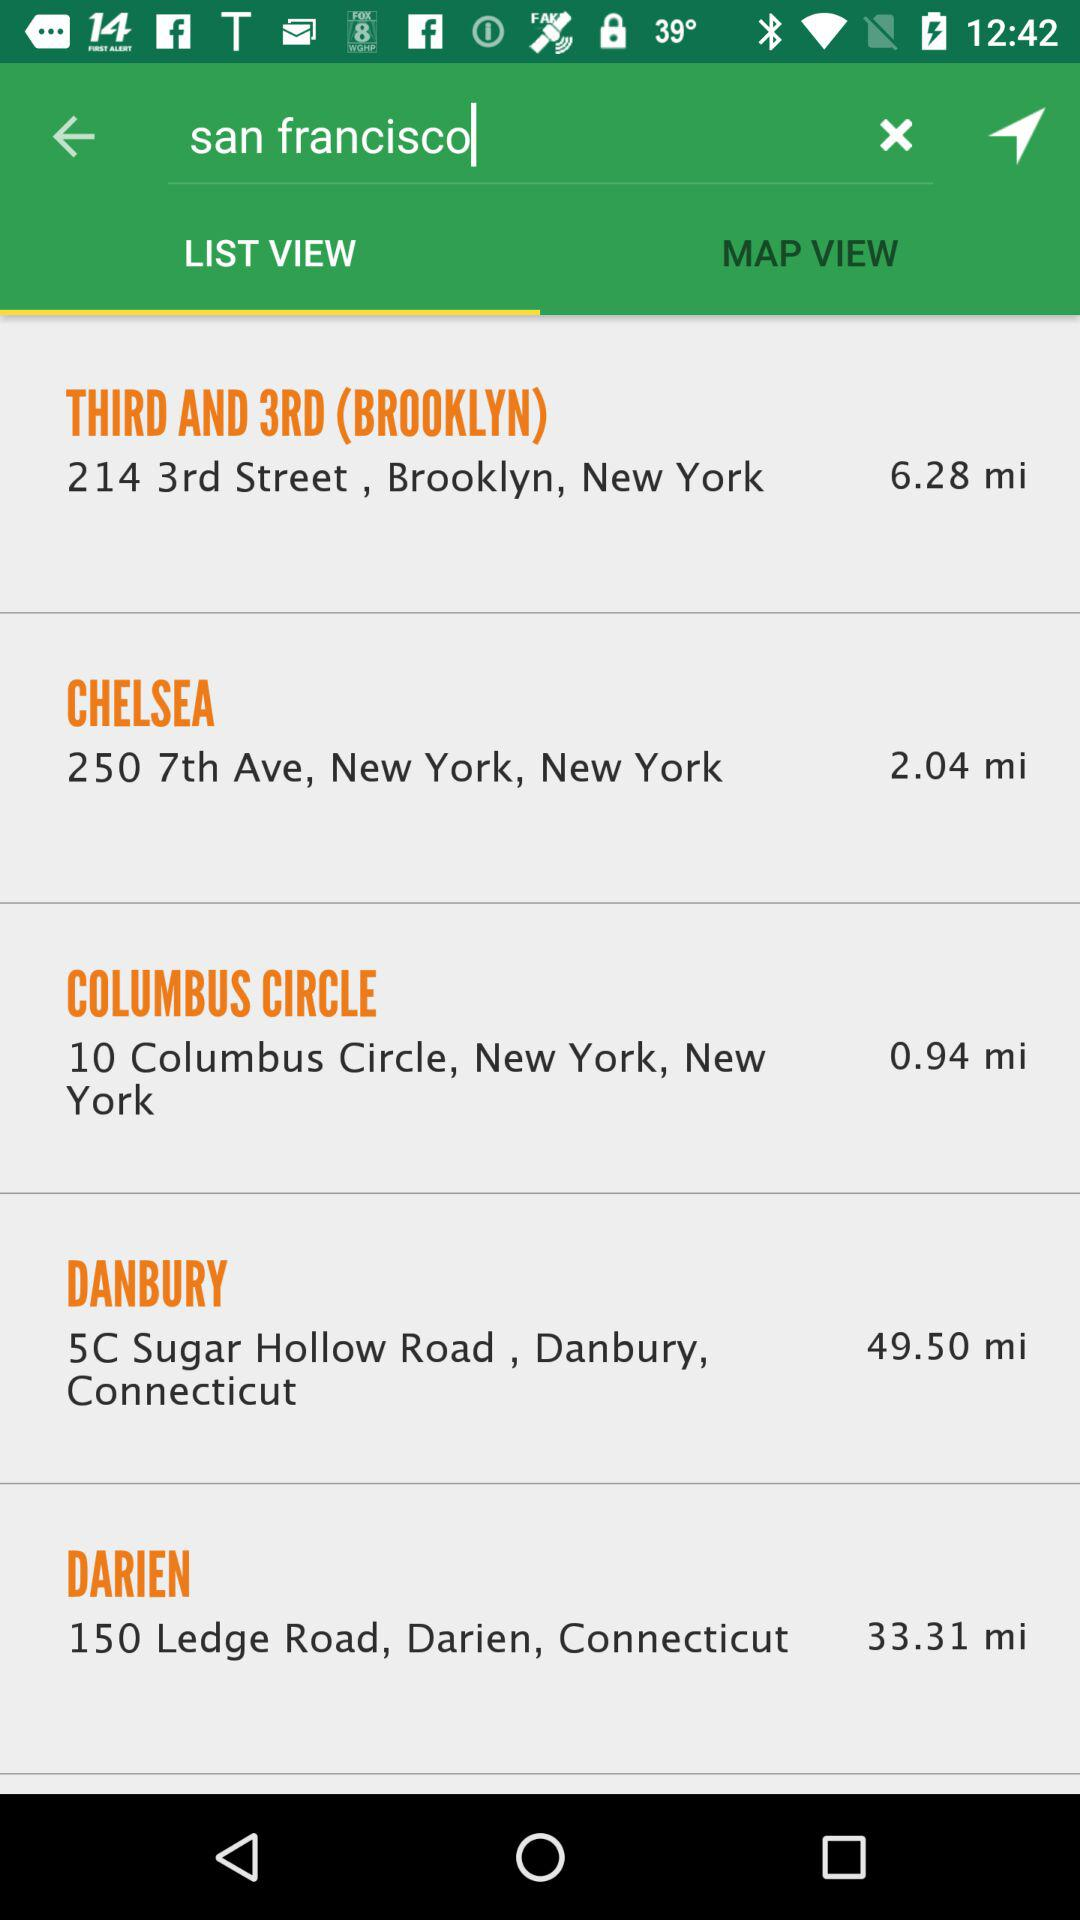How far is Darien? Darien is 33.31 miles away. 